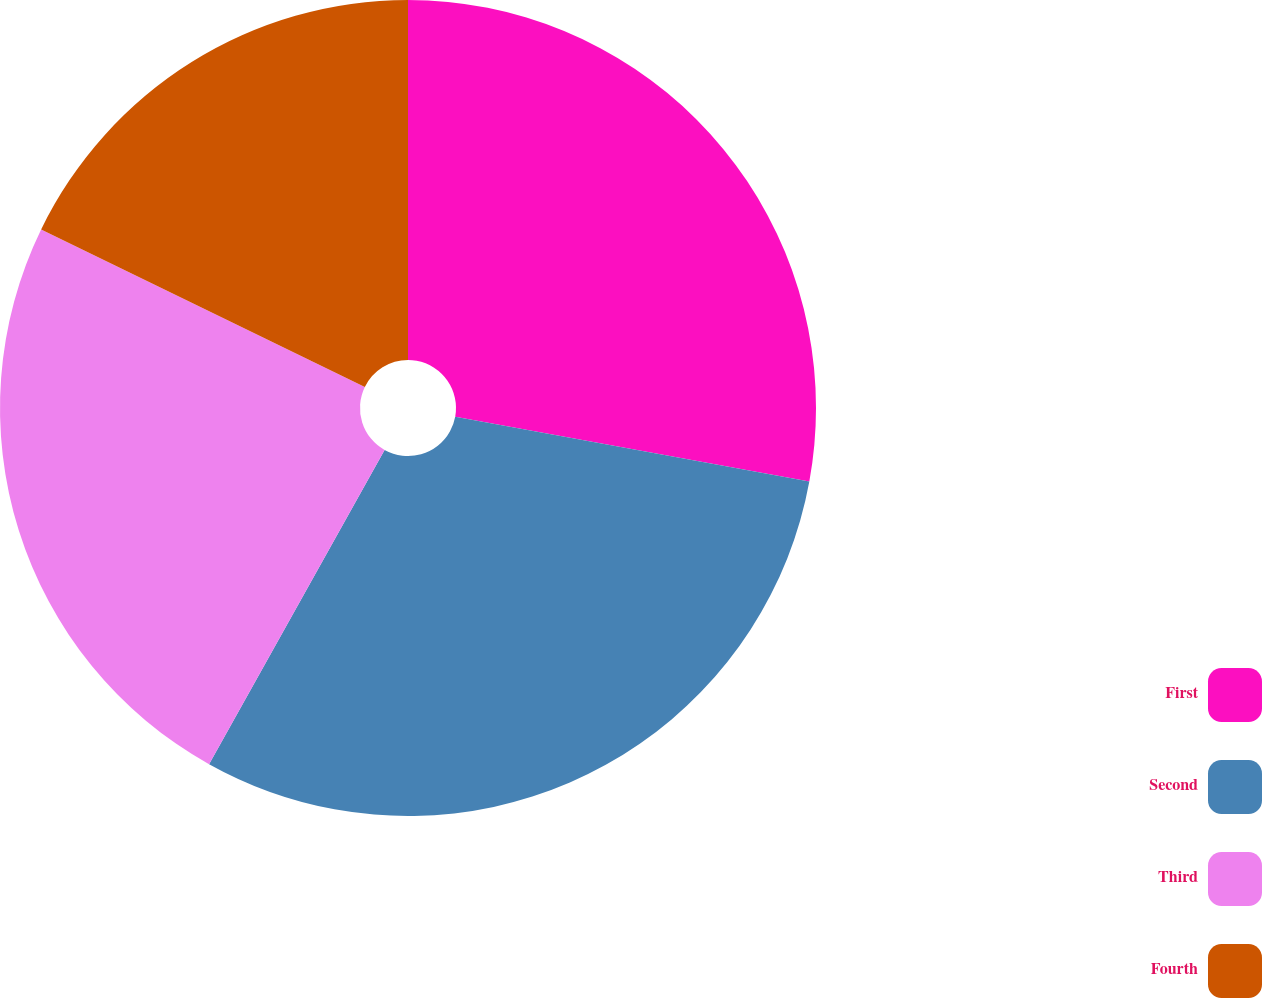<chart> <loc_0><loc_0><loc_500><loc_500><pie_chart><fcel>First<fcel>Second<fcel>Third<fcel>Fourth<nl><fcel>27.88%<fcel>30.22%<fcel>24.1%<fcel>17.79%<nl></chart> 